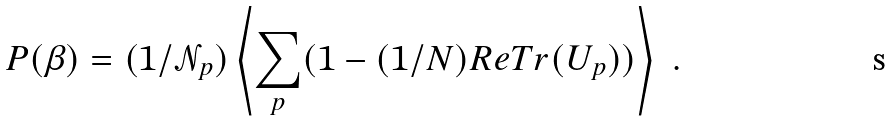Convert formula to latex. <formula><loc_0><loc_0><loc_500><loc_500>P ( \beta ) = ( 1 / \mathcal { N } _ { p } ) \left \langle \sum _ { p } ( 1 - ( 1 / N ) R e T r ( U _ { p } ) ) \right \rangle \ .</formula> 